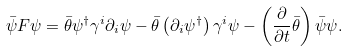<formula> <loc_0><loc_0><loc_500><loc_500>\bar { \psi } F \psi = \bar { \theta } \psi ^ { \dag } \gamma ^ { i } \partial _ { i } \psi - \bar { \theta } \left ( \partial _ { i } \psi ^ { \dag } \right ) \gamma ^ { i } \psi - \left ( \frac { \partial } { \partial t } \bar { \theta } \right ) \bar { \psi } \psi .</formula> 